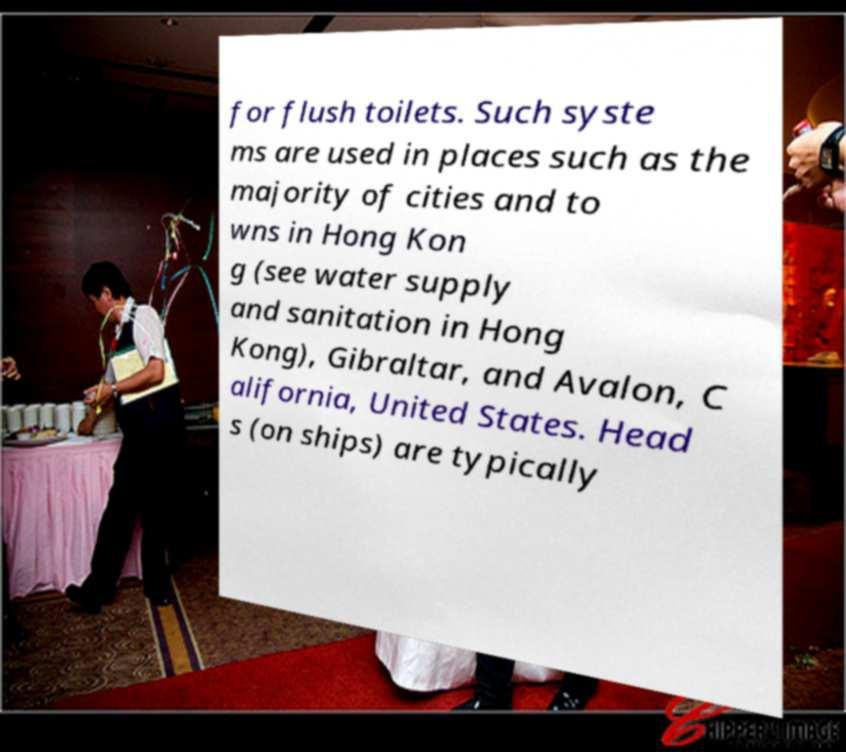Can you read and provide the text displayed in the image?This photo seems to have some interesting text. Can you extract and type it out for me? for flush toilets. Such syste ms are used in places such as the majority of cities and to wns in Hong Kon g (see water supply and sanitation in Hong Kong), Gibraltar, and Avalon, C alifornia, United States. Head s (on ships) are typically 